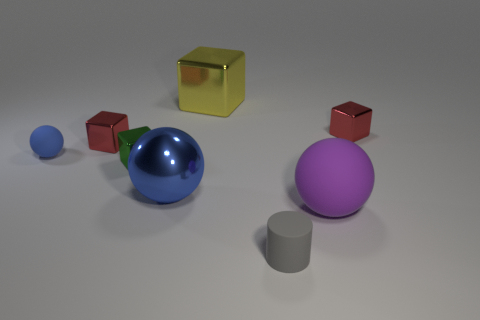There is another sphere that is the same color as the tiny matte sphere; what material is it?
Provide a succinct answer. Metal. There is a tiny red shiny cube on the left side of the red metal block right of the large rubber thing; is there a gray rubber object to the right of it?
Provide a succinct answer. Yes. Is the number of tiny rubber cylinders to the left of the big blue object less than the number of purple rubber objects in front of the purple rubber ball?
Keep it short and to the point. No. There is another big thing that is made of the same material as the gray object; what color is it?
Provide a short and direct response. Purple. The rubber object that is in front of the rubber sphere in front of the small green metallic thing is what color?
Offer a very short reply. Gray. Are there any tiny things of the same color as the metal sphere?
Make the answer very short. Yes. What shape is the blue matte thing that is the same size as the gray rubber cylinder?
Offer a very short reply. Sphere. How many small rubber objects are in front of the green metallic object that is in front of the big shiny cube?
Your answer should be very brief. 1. Do the small matte sphere and the big metal sphere have the same color?
Make the answer very short. Yes. How many other things are there of the same material as the big yellow thing?
Ensure brevity in your answer.  4. 